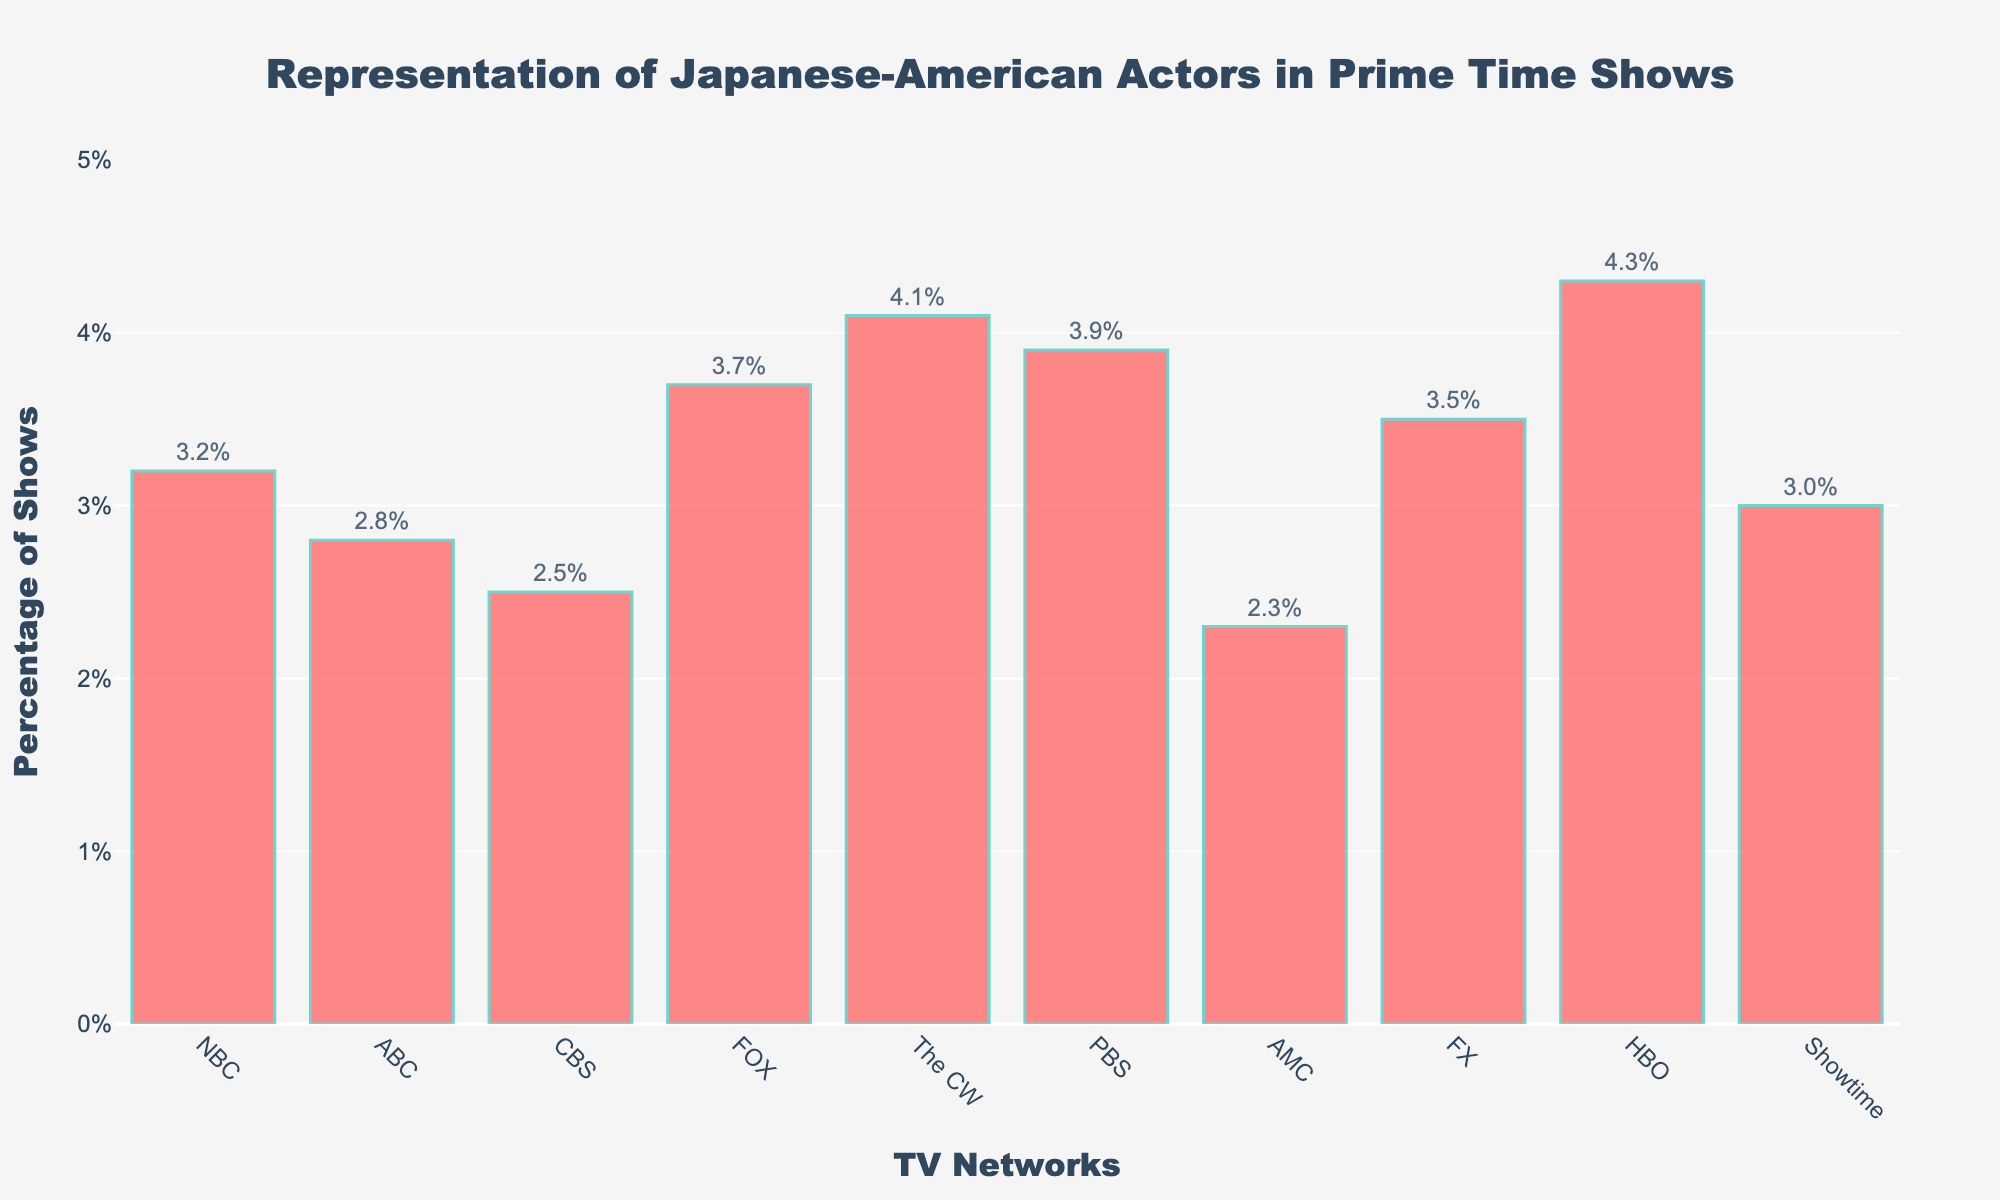What percentage of shows on NBC feature Japanese-American actors? Locate the bar representing NBC on the x-axis and read the corresponding value on the y-axis.
Answer: 3.2% Which network has the highest percentage of shows with Japanese-American actors? Identify the bar that reaches the highest point on the y-axis.
Answer: HBO How does the representation percentage on PBS compare to NBC? Identify the heights of both the PBS and NBC bars. PBS is at 3.9% and NBC is at 3.2%. Compare these values.
Answer: PBS is higher What is the average percentage of shows featuring Japanese-American actors across all networks? Add up all percentages: 3.2 + 2.8 + 2.5 + 3.7 + 4.1 + 3.9 + 2.3 + 3.5 + 4.3 + 3.0 = 33.3. Then divide by the number of networks, which is 10.
Answer: 3.33% Which network features Japanese-American actors in prime time shows more, ABC or Showtime? Locate the bars for ABC and Showtime and compare their heights. ABC is at 2.8% and Showtime is at 3.0%.
Answer: Showtime What is the difference in percentage representation between AMC and HBO? Find the percentage values for AMC (2.3%) and HBO (4.3%), then calculate the difference. 4.3 - 2.3 = 2.0
Answer: 2.0% List the networks with more than 3% of shows featuring Japanese-American actors. Identify bars reaching above the 3% mark on the y-axis. These are NBC, FOX, The CW, PBS, FX, and HBO.
Answer: NBC, FOX, The CW, PBS, FX, HBO What's the total percentage of Japanese-American representation for networks with less than 3% representation? Identify networks below the 3% threshold: ABC (2.8%), CBS (2.5%), AMC (2.3%). Calculate their sum: 2.8 + 2.5 + 2.3 = 7.6%.
Answer: 7.6% How many networks have a representation percentage between 3% and 4%? Identify the bars where the y-axis values are between 3% and 4%. These are NBC, FOX, PBS, FX, and Showtime. Count them.
Answer: 5 